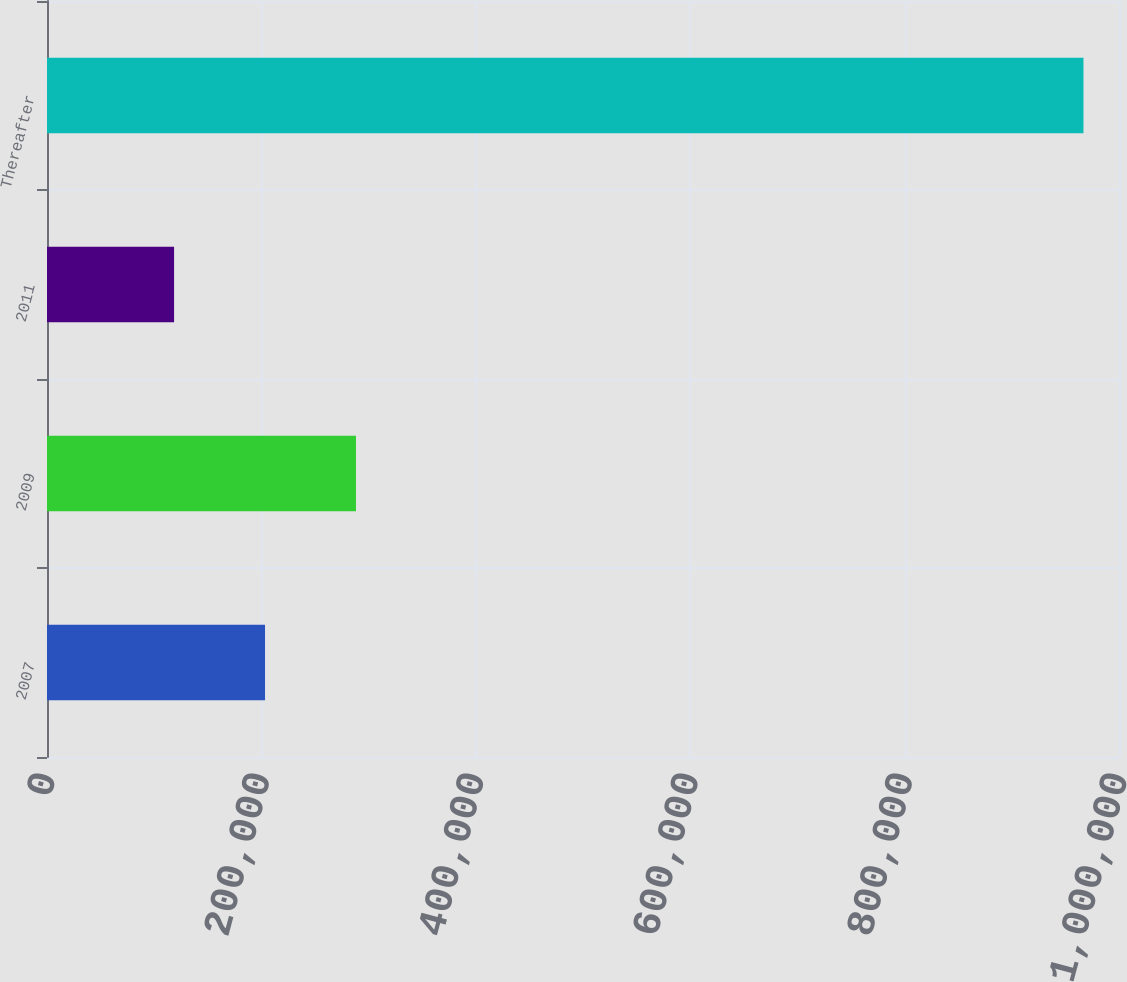Convert chart. <chart><loc_0><loc_0><loc_500><loc_500><bar_chart><fcel>2007<fcel>2009<fcel>2011<fcel>Thereafter<nl><fcel>203379<fcel>288208<fcel>118549<fcel>966845<nl></chart> 